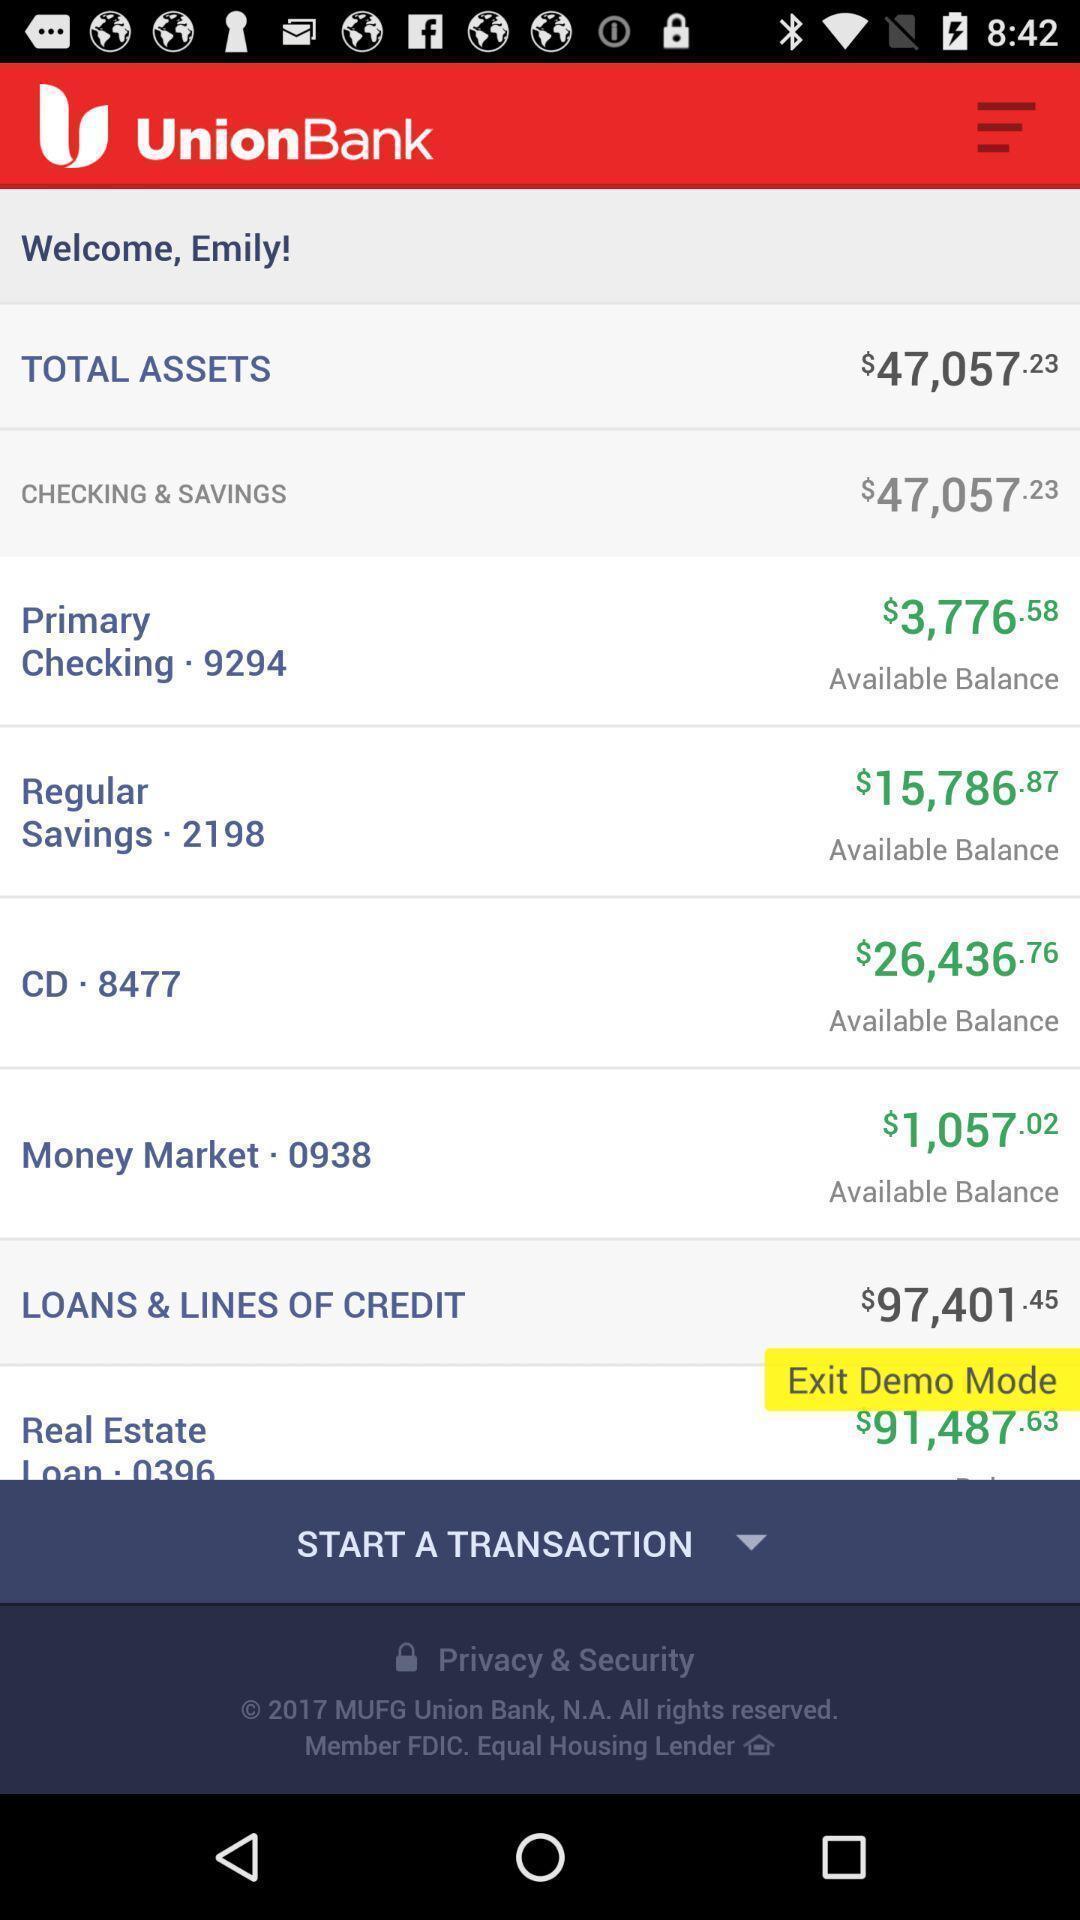Describe the content in this image. Transaction of a statement history. 